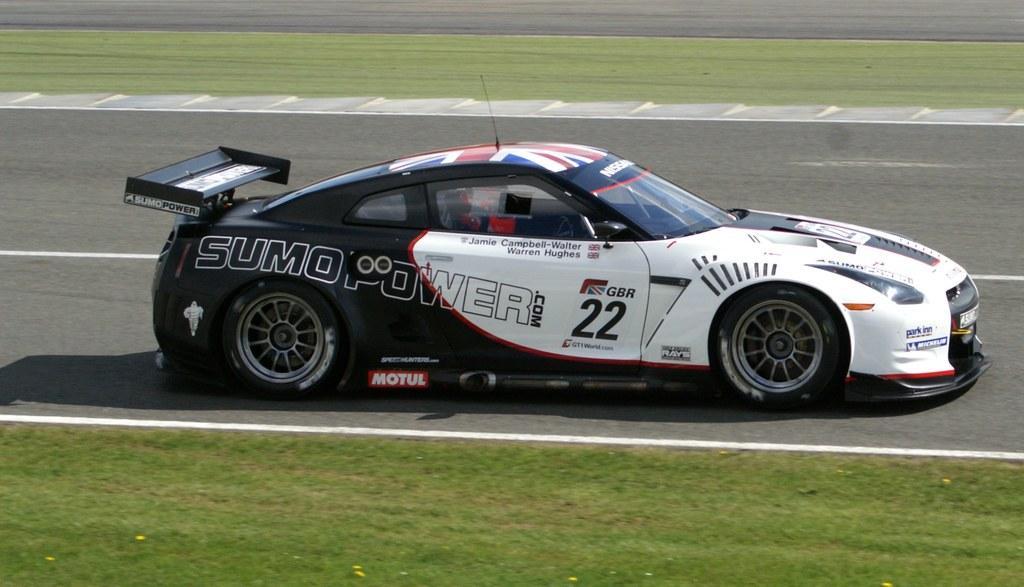Could you give a brief overview of what you see in this image? In this image, we can see a car on the road. There is a grass on the ground. 